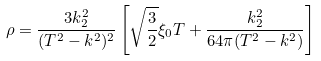<formula> <loc_0><loc_0><loc_500><loc_500>\rho = \frac { 3 k ^ { 2 } _ { 2 } } { ( T ^ { 2 } - k ^ { 2 } ) ^ { 2 } } \left [ \sqrt { \frac { 3 } { 2 } } \xi _ { 0 } T + \frac { k ^ { 2 } _ { 2 } } { 6 4 \pi ( T ^ { 2 } - k ^ { 2 } ) } \right ]</formula> 